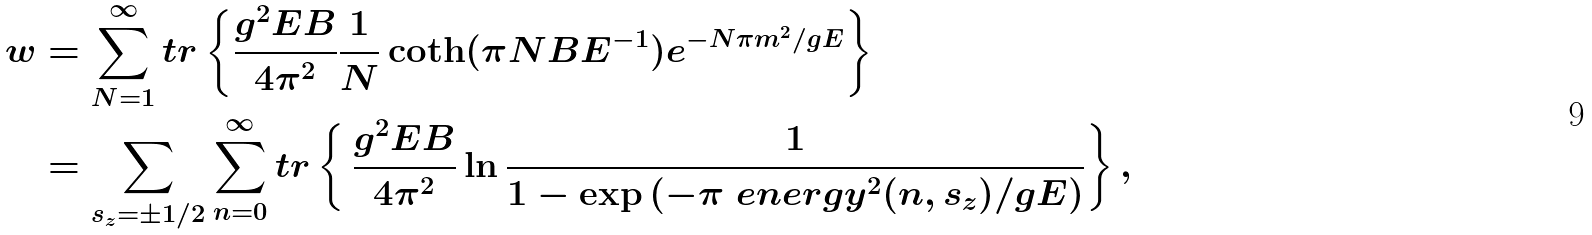<formula> <loc_0><loc_0><loc_500><loc_500>w & = \sum _ { N = 1 } ^ { \infty } t r \left \{ \frac { g ^ { 2 } E B } { 4 \pi ^ { 2 } } \frac { 1 } { N } \coth ( \pi N B E ^ { - 1 } ) e ^ { - N \pi m ^ { 2 } / g E } \right \} \\ & = \sum _ { s _ { z } = \pm 1 / 2 } \sum _ { n = 0 } ^ { \infty } t r \left \{ \, \frac { g ^ { 2 } E B } { 4 \pi ^ { 2 } } \ln \frac { 1 } { 1 - \exp { ( - \pi \ e n e r g y ^ { 2 } ( n , s _ { z } ) / g E } ) } \right \} ,</formula> 